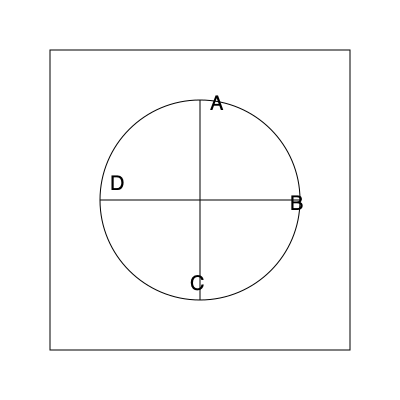Imagine this diagram represents a top-down view of a circular mixing console. If you were to rotate the console 90 degrees clockwise, which label would be at the top position? To solve this problem, we need to mentally rotate the mixing console 90 degrees clockwise. Let's follow these steps:

1. Identify the current positions:
   - A is at the top
   - B is on the right
   - C is at the bottom
   - D is on the left

2. Visualize a 90-degree clockwise rotation:
   - The top position (A) will move to the right
   - The right position (B) will move to the bottom
   - The bottom position (C) will move to the left
   - The left position (D) will move to the top

3. After the rotation:
   - D will be at the top
   - A will be on the right
   - B will be at the bottom
   - C will be on the left

Therefore, after a 90-degree clockwise rotation, the label D will be at the top position.
Answer: D 